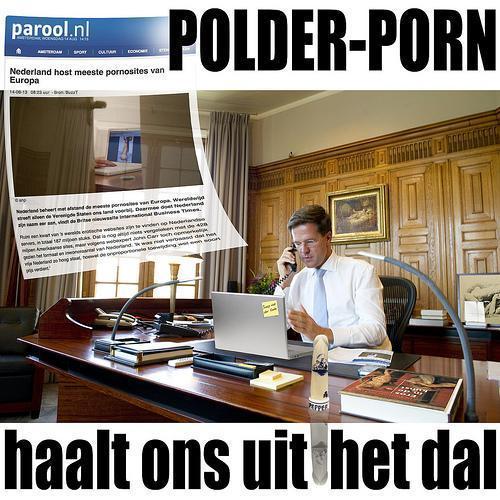How many people are here?
Give a very brief answer. 1. 